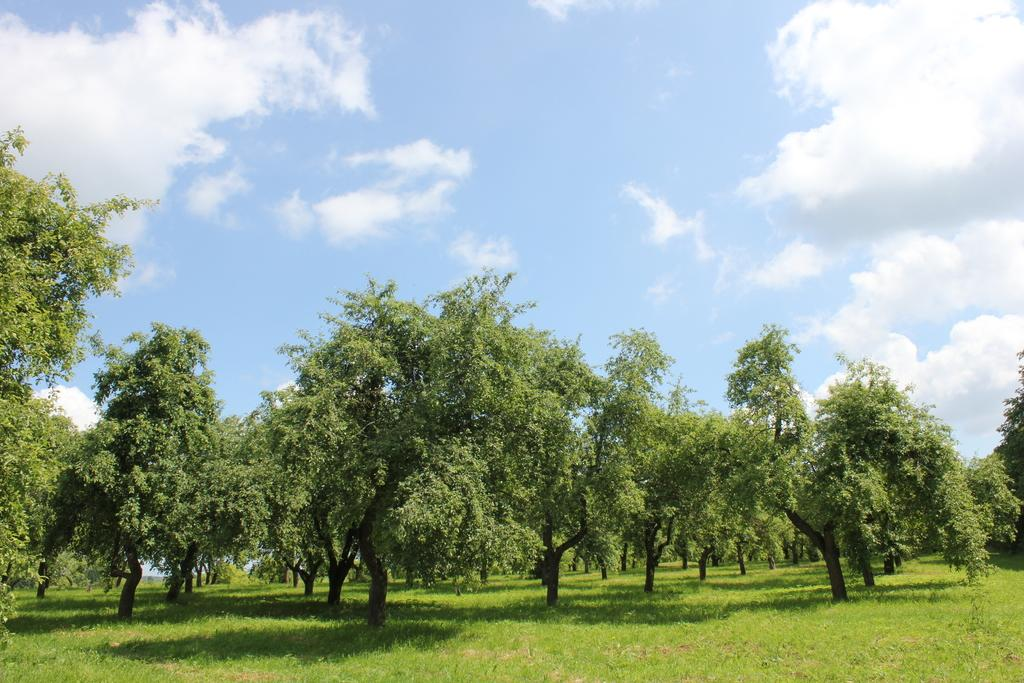What type of vegetation is in the center of the image? There are trees in the center of the image. What type of ground cover is at the bottom of the image? There is grass at the bottom of the image. What part of the natural environment is visible at the top of the image? The sky is visible at the top of the image. What type of voice can be heard coming from the trees in the image? There is no voice present in the image, as it is a still image of trees, grass, and sky. What is the quiver used for in the image? There is no quiver present in the image. 